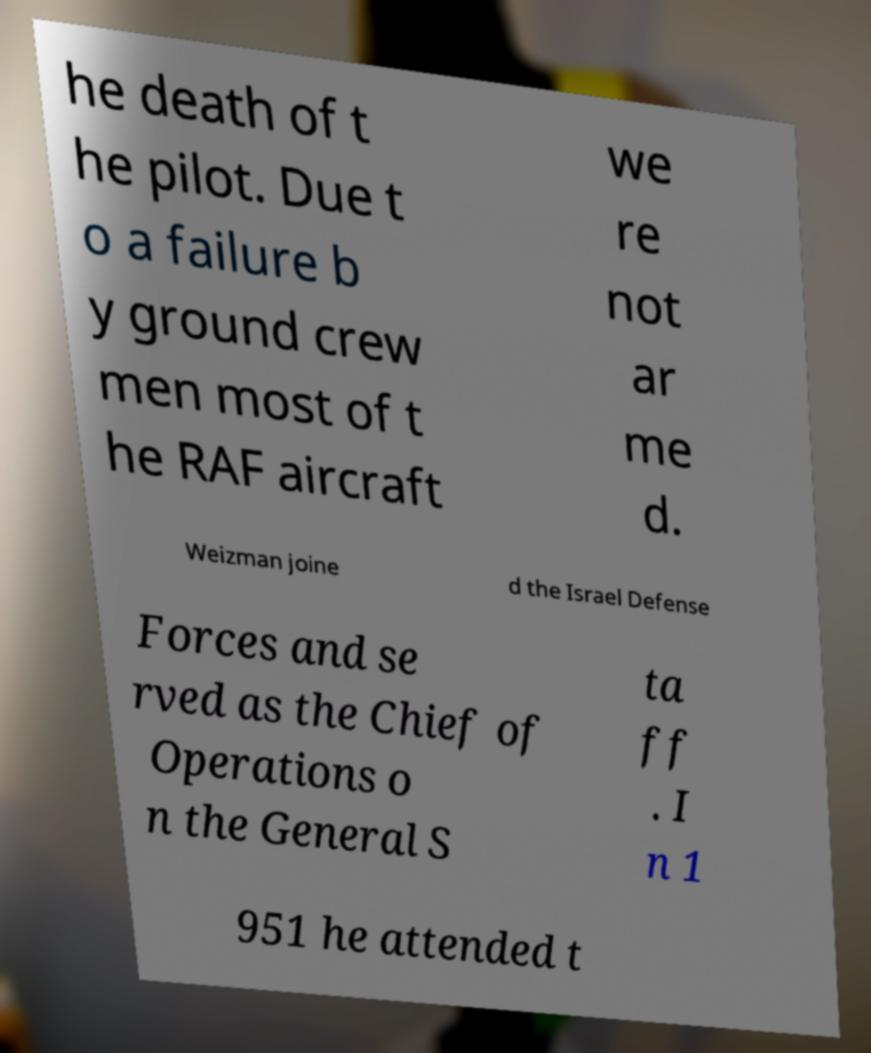Please read and relay the text visible in this image. What does it say? he death of t he pilot. Due t o a failure b y ground crew men most of t he RAF aircraft we re not ar me d. Weizman joine d the Israel Defense Forces and se rved as the Chief of Operations o n the General S ta ff . I n 1 951 he attended t 